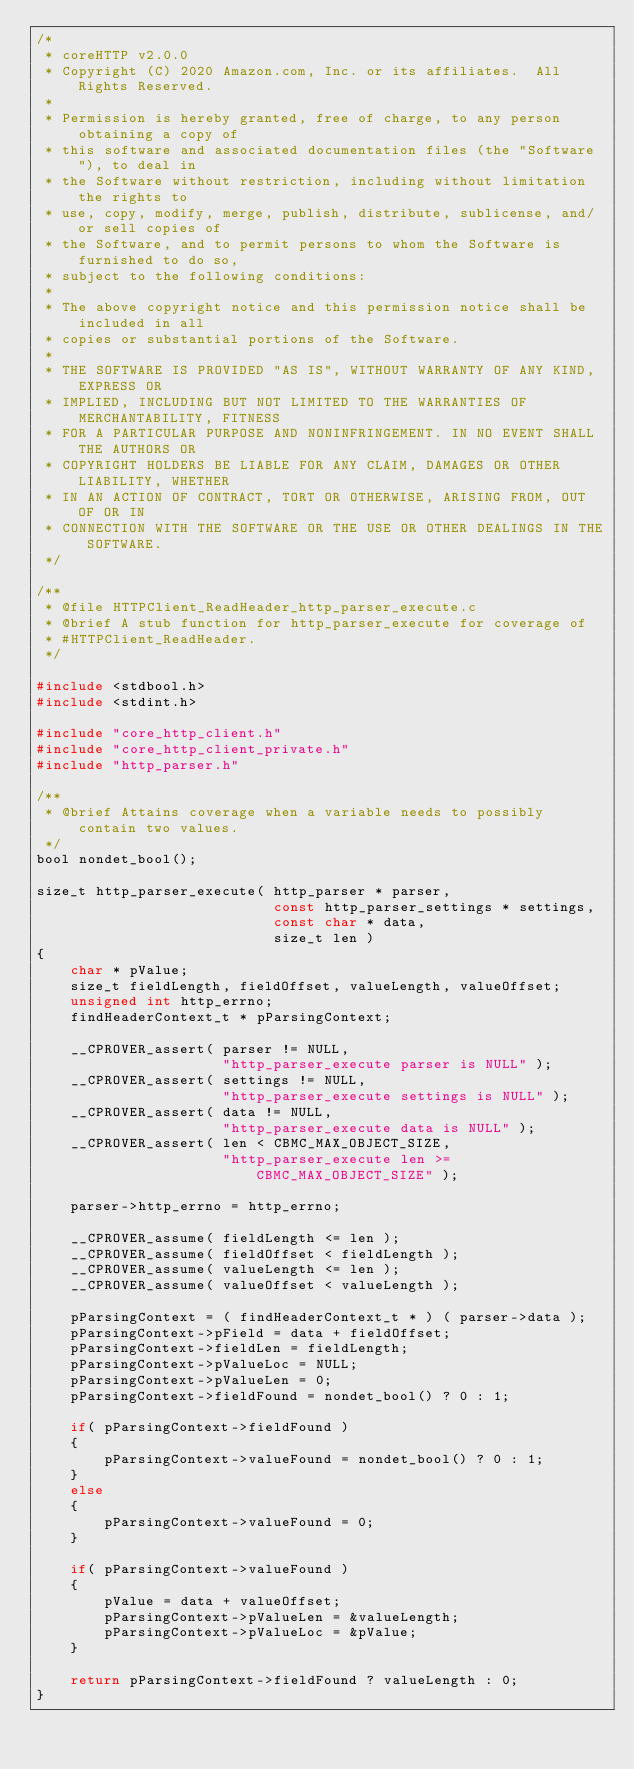<code> <loc_0><loc_0><loc_500><loc_500><_C_>/*
 * coreHTTP v2.0.0
 * Copyright (C) 2020 Amazon.com, Inc. or its affiliates.  All Rights Reserved.
 *
 * Permission is hereby granted, free of charge, to any person obtaining a copy of
 * this software and associated documentation files (the "Software"), to deal in
 * the Software without restriction, including without limitation the rights to
 * use, copy, modify, merge, publish, distribute, sublicense, and/or sell copies of
 * the Software, and to permit persons to whom the Software is furnished to do so,
 * subject to the following conditions:
 *
 * The above copyright notice and this permission notice shall be included in all
 * copies or substantial portions of the Software.
 *
 * THE SOFTWARE IS PROVIDED "AS IS", WITHOUT WARRANTY OF ANY KIND, EXPRESS OR
 * IMPLIED, INCLUDING BUT NOT LIMITED TO THE WARRANTIES OF MERCHANTABILITY, FITNESS
 * FOR A PARTICULAR PURPOSE AND NONINFRINGEMENT. IN NO EVENT SHALL THE AUTHORS OR
 * COPYRIGHT HOLDERS BE LIABLE FOR ANY CLAIM, DAMAGES OR OTHER LIABILITY, WHETHER
 * IN AN ACTION OF CONTRACT, TORT OR OTHERWISE, ARISING FROM, OUT OF OR IN
 * CONNECTION WITH THE SOFTWARE OR THE USE OR OTHER DEALINGS IN THE SOFTWARE.
 */

/**
 * @file HTTPClient_ReadHeader_http_parser_execute.c
 * @brief A stub function for http_parser_execute for coverage of
 * #HTTPClient_ReadHeader.
 */

#include <stdbool.h>
#include <stdint.h>

#include "core_http_client.h"
#include "core_http_client_private.h"
#include "http_parser.h"

/**
 * @brief Attains coverage when a variable needs to possibly contain two values.
 */
bool nondet_bool();

size_t http_parser_execute( http_parser * parser,
                            const http_parser_settings * settings,
                            const char * data,
                            size_t len )
{
    char * pValue;
    size_t fieldLength, fieldOffset, valueLength, valueOffset;
    unsigned int http_errno;
    findHeaderContext_t * pParsingContext;

    __CPROVER_assert( parser != NULL,
                      "http_parser_execute parser is NULL" );
    __CPROVER_assert( settings != NULL,
                      "http_parser_execute settings is NULL" );
    __CPROVER_assert( data != NULL,
                      "http_parser_execute data is NULL" );
    __CPROVER_assert( len < CBMC_MAX_OBJECT_SIZE,
                      "http_parser_execute len >= CBMC_MAX_OBJECT_SIZE" );

    parser->http_errno = http_errno;

    __CPROVER_assume( fieldLength <= len );
    __CPROVER_assume( fieldOffset < fieldLength );
    __CPROVER_assume( valueLength <= len );
    __CPROVER_assume( valueOffset < valueLength );

    pParsingContext = ( findHeaderContext_t * ) ( parser->data );
    pParsingContext->pField = data + fieldOffset;
    pParsingContext->fieldLen = fieldLength;
    pParsingContext->pValueLoc = NULL;
    pParsingContext->pValueLen = 0;
    pParsingContext->fieldFound = nondet_bool() ? 0 : 1;

    if( pParsingContext->fieldFound )
    {
        pParsingContext->valueFound = nondet_bool() ? 0 : 1;
    }
    else
    {
        pParsingContext->valueFound = 0;
    }

    if( pParsingContext->valueFound )
    {
        pValue = data + valueOffset;
        pParsingContext->pValueLen = &valueLength;
        pParsingContext->pValueLoc = &pValue;
    }

    return pParsingContext->fieldFound ? valueLength : 0;
}
</code> 